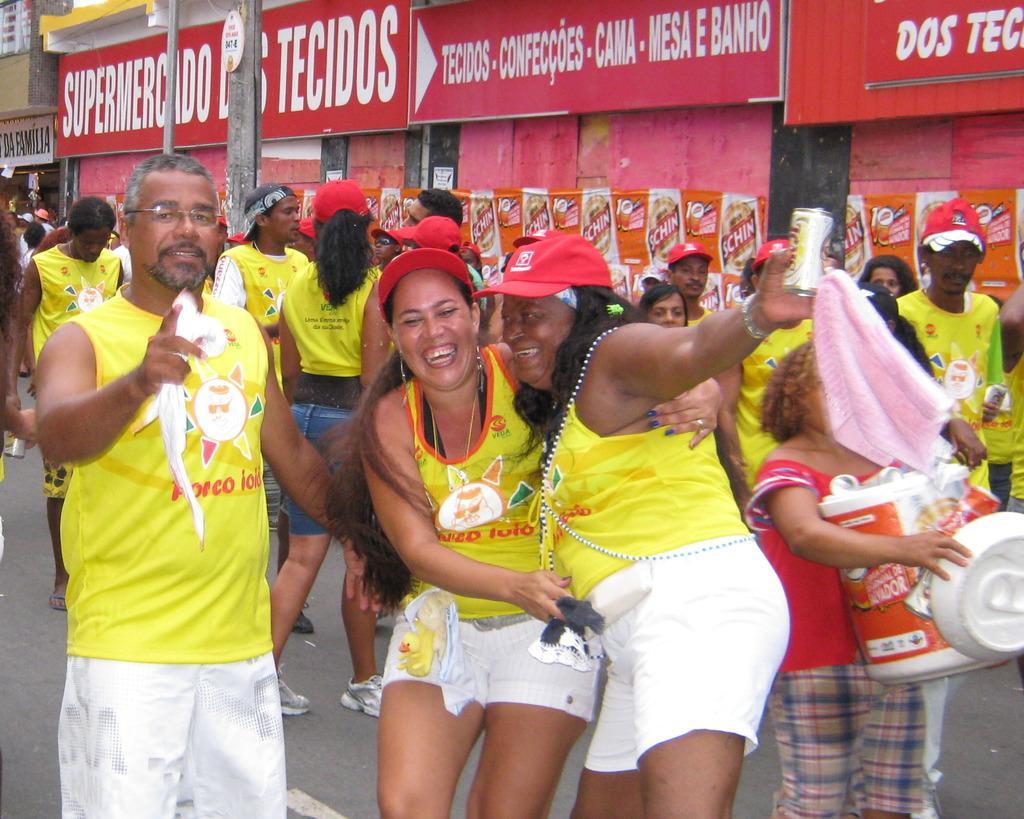In one or two sentences, can you explain what this image depicts? In the foreground of the picture we can see many people wearing yellow color dresses. In the background there are boards, banners, poles and buildings. 